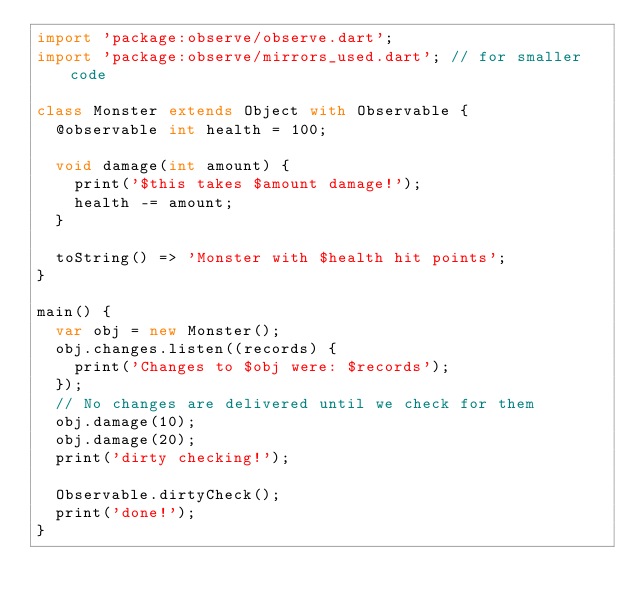<code> <loc_0><loc_0><loc_500><loc_500><_Dart_>import 'package:observe/observe.dart';
import 'package:observe/mirrors_used.dart'; // for smaller code

class Monster extends Object with Observable {
  @observable int health = 100;

  void damage(int amount) {
    print('$this takes $amount damage!');
    health -= amount;
  }

  toString() => 'Monster with $health hit points';
}

main() {
  var obj = new Monster();
  obj.changes.listen((records) {
    print('Changes to $obj were: $records');
  });
  // No changes are delivered until we check for them
  obj.damage(10);
  obj.damage(20);
  print('dirty checking!');

  Observable.dirtyCheck();
  print('done!');
}</code> 